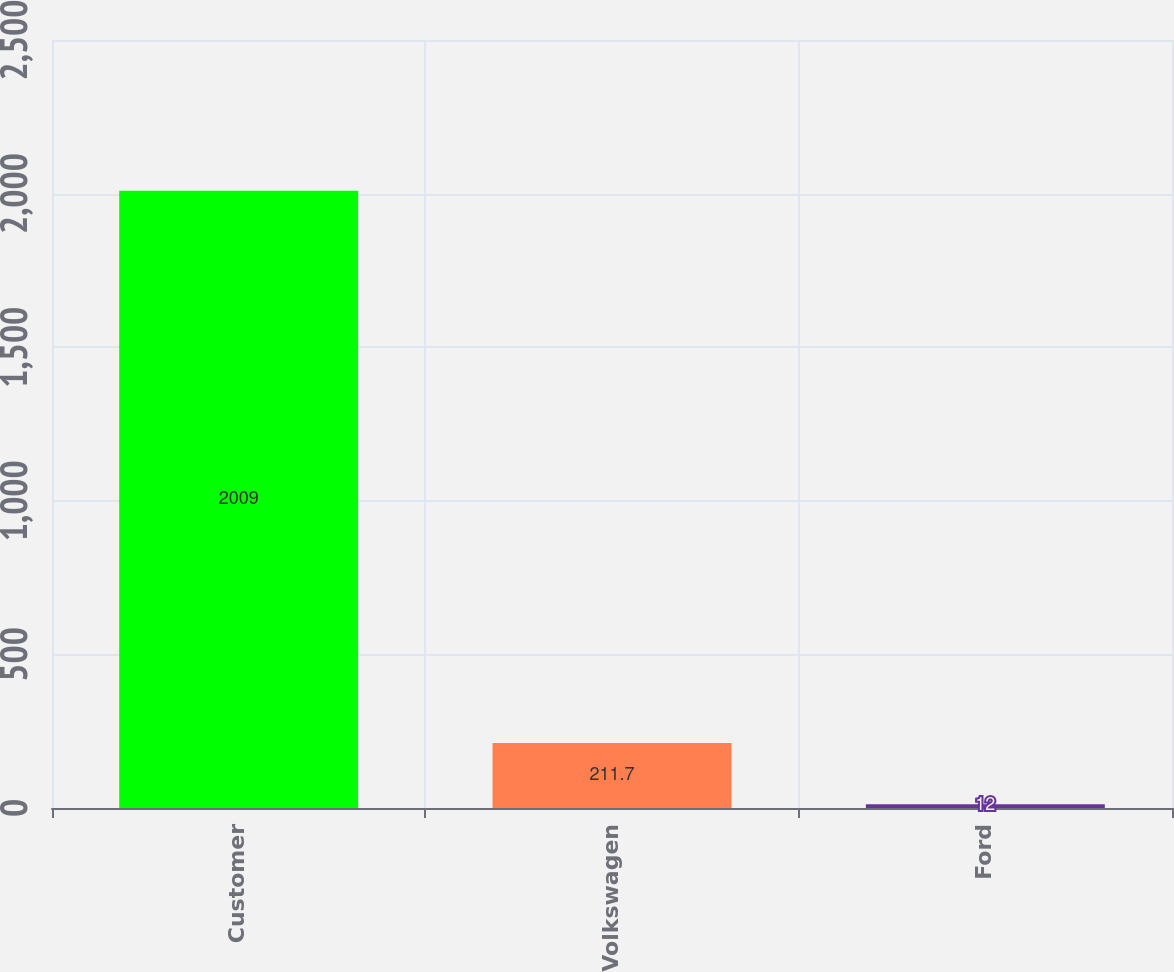<chart> <loc_0><loc_0><loc_500><loc_500><bar_chart><fcel>Customer<fcel>Volkswagen<fcel>Ford<nl><fcel>2009<fcel>211.7<fcel>12<nl></chart> 